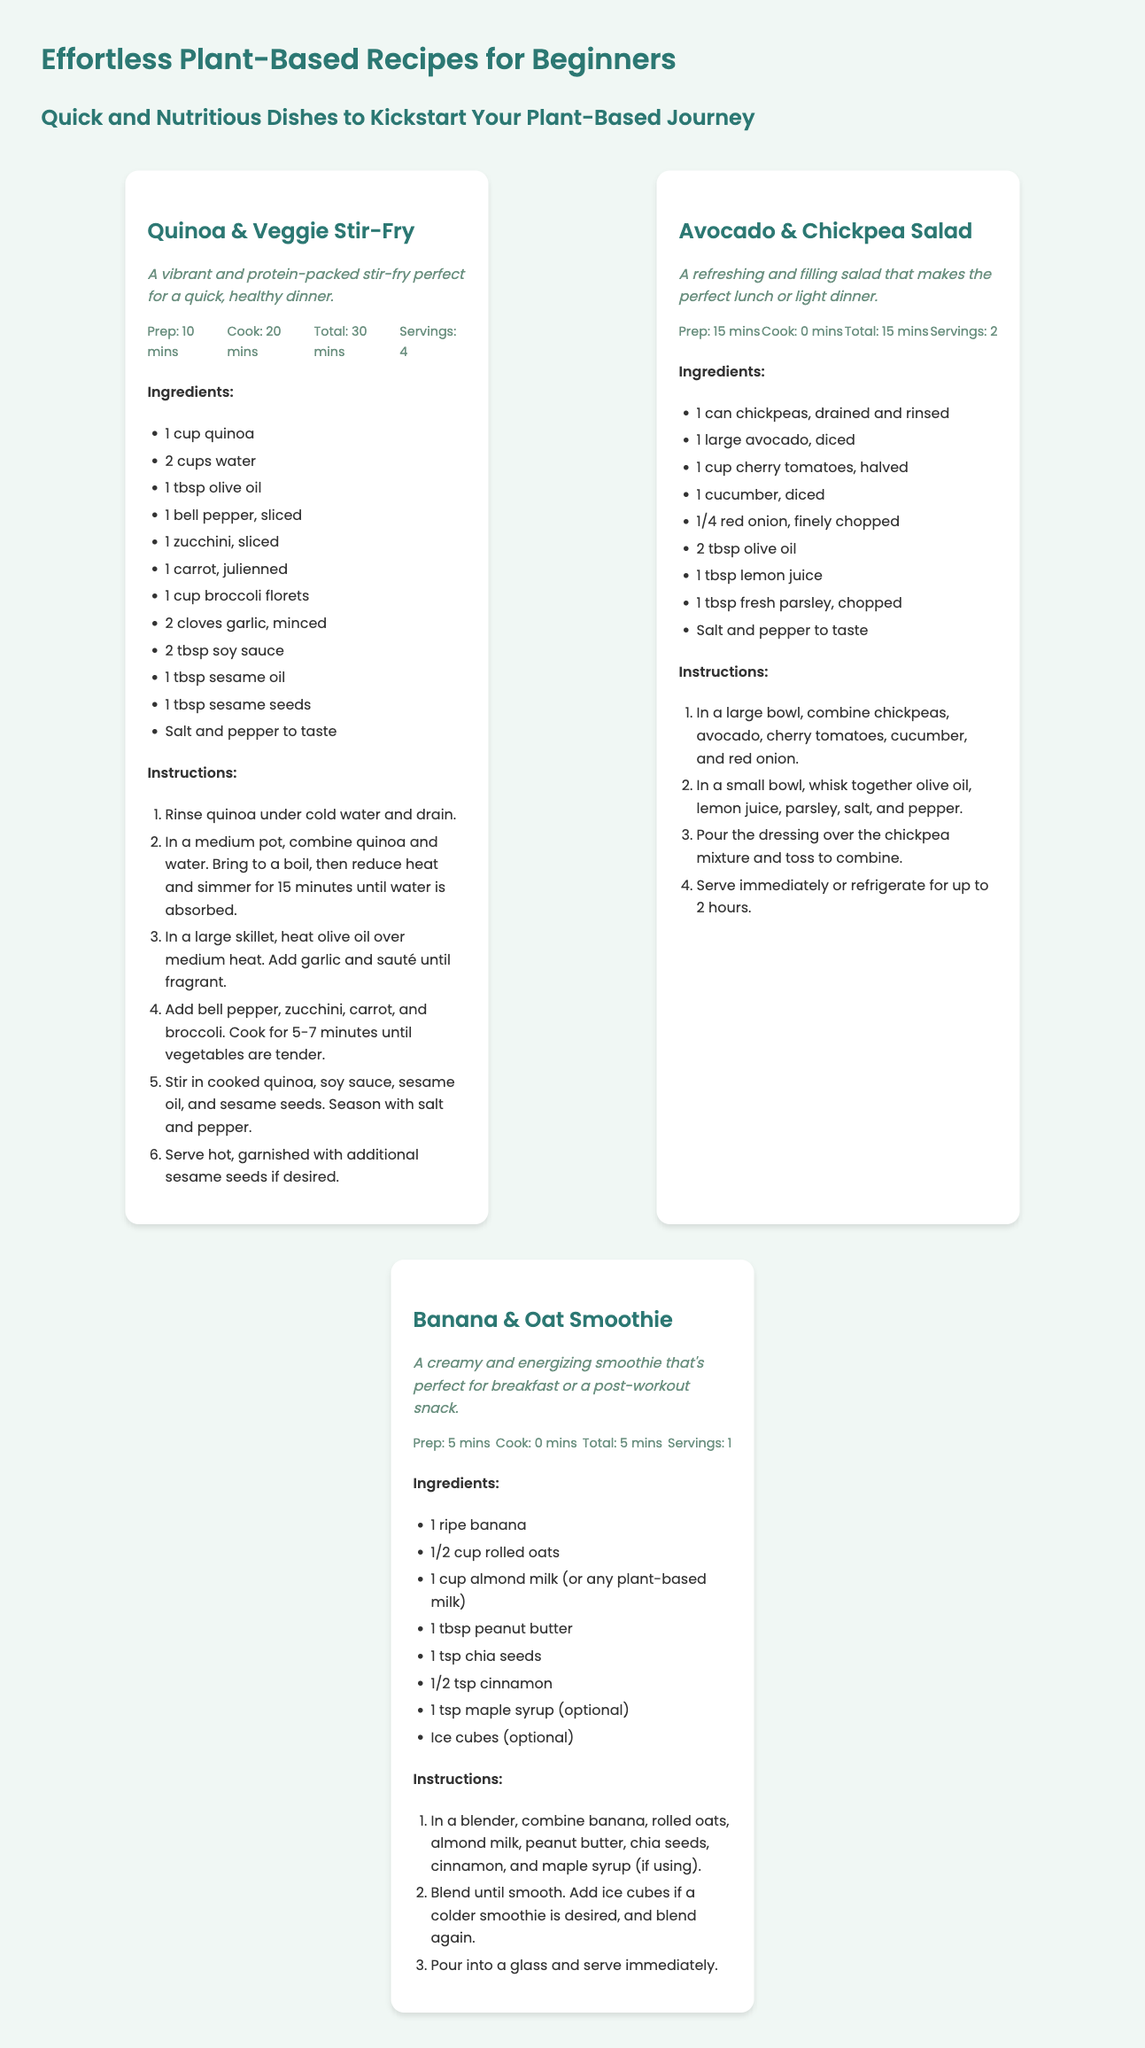What is the total prep time for Quinoa & Veggie Stir-Fry? The prep time for Quinoa & Veggie Stir-Fry is 10 minutes, as indicated in the recipe details.
Answer: 10 mins How many servings does the Avocado & Chickpea Salad yield? The Avocado & Chickpea Salad yields 2 servings, as stated in the recipe card.
Answer: 2 What is the main ingredient in the Banana & Oat Smoothie? The main ingredient in the Banana & Oat Smoothie is a ripe banana, as listed in the ingredients section.
Answer: Banana How long does it take to cook the Quinoa & Veggie Stir-Fry? The cooking time for Quinoa & Veggie Stir-Fry is 20 minutes, according to the recipe details.
Answer: 20 mins What type of oil is used in the Avocado & Chickpea Salad? The Avocado & Chickpea Salad uses olive oil, mentioned in the ingredients list.
Answer: Olive oil How many ingredients are listed for the Banana & Oat Smoothie? There are 8 ingredients listed for the Banana & Oat Smoothie, as seen in the ingredients section.
Answer: 8 What method is used to prepare the Quinoa & Veggie Stir-Fry? The method used is sautéing, as described in the instructions for cooking the dish.
Answer: Sautéing What ingredients are used in the dressing for the Avocado & Chickpea Salad? The dressing includes olive oil, lemon juice, parsley, salt, and pepper, as listed in the instructions.
Answer: Olive oil, lemon juice, parsley, salt, and pepper What is the total time to prepare and cook the Quinoa & Veggie Stir-Fry? The total time to prepare and cook the Quinoa & Veggie Stir-Fry is 30 minutes, as detailed in the recipe card.
Answer: 30 mins 